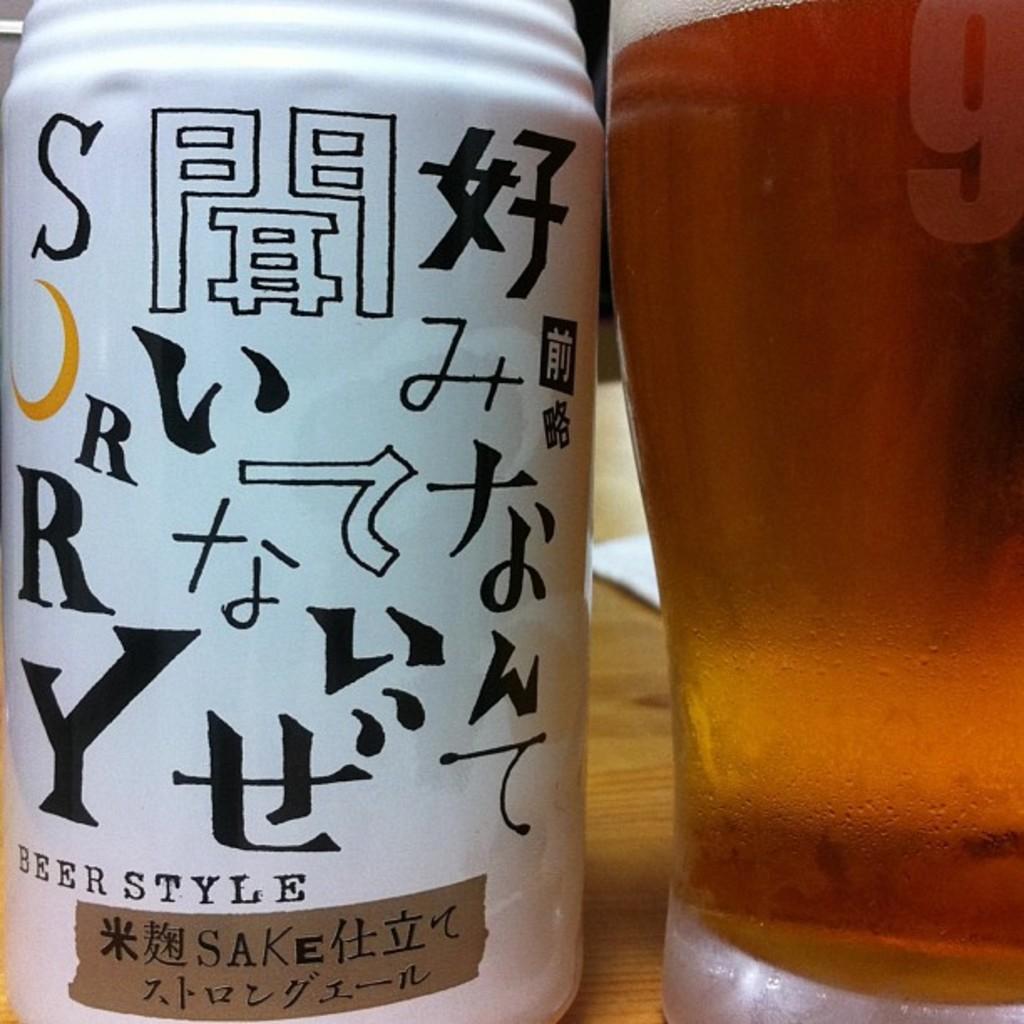What style is this drink?
Offer a very short reply. Beer. What is the letter on the top left?
Offer a terse response. S. 